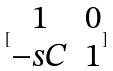<formula> <loc_0><loc_0><loc_500><loc_500>[ \begin{matrix} 1 & 0 \\ - s C & 1 \end{matrix} ]</formula> 